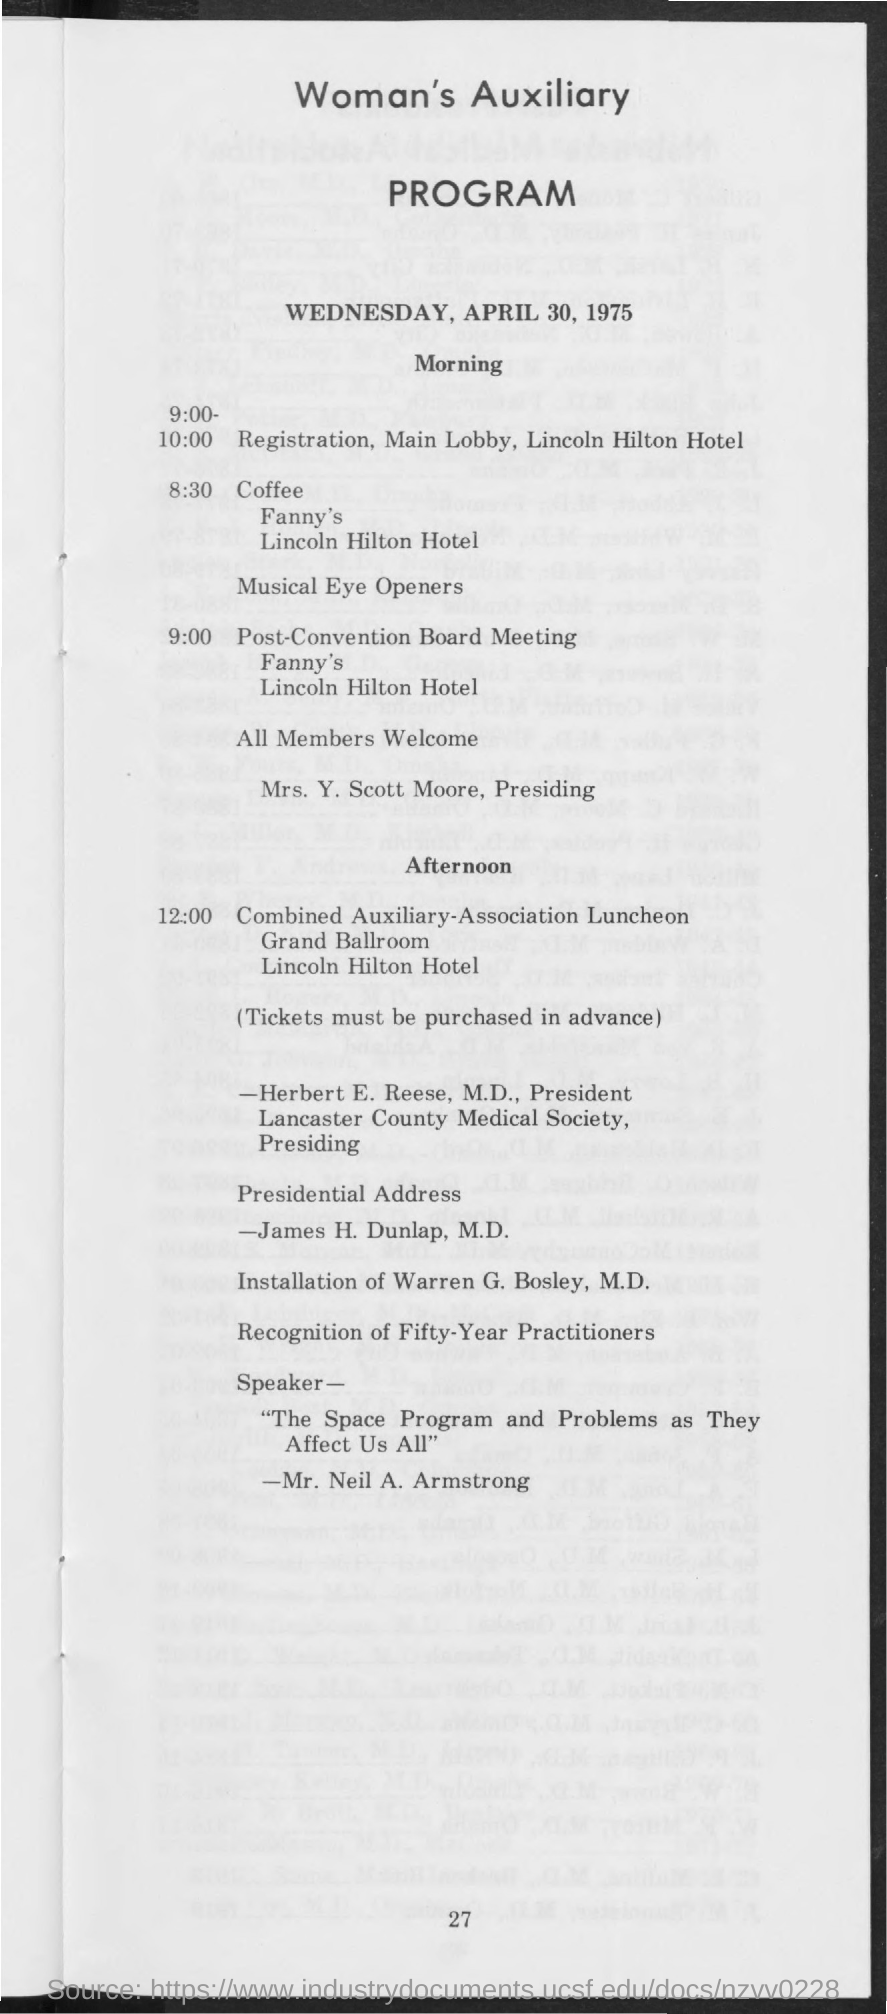What is the date mentioned in the document?
Give a very brief answer. Wednesday, april 30, 1975. 